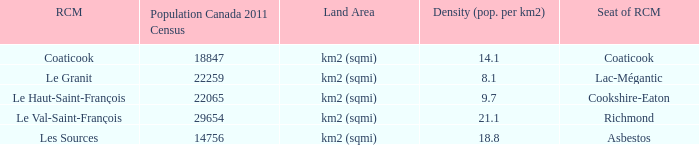What is the land area for the RCM that has a population of 18847? Km2 (sqmi). 